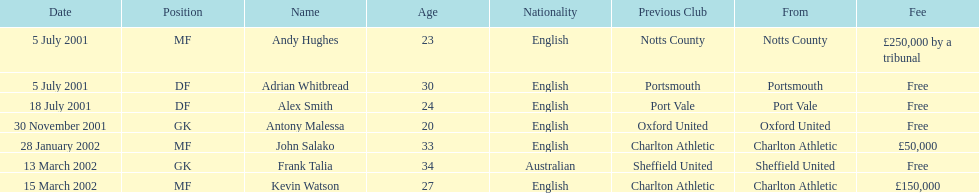What was the transfer charge for moving kevin watson? £150,000. 